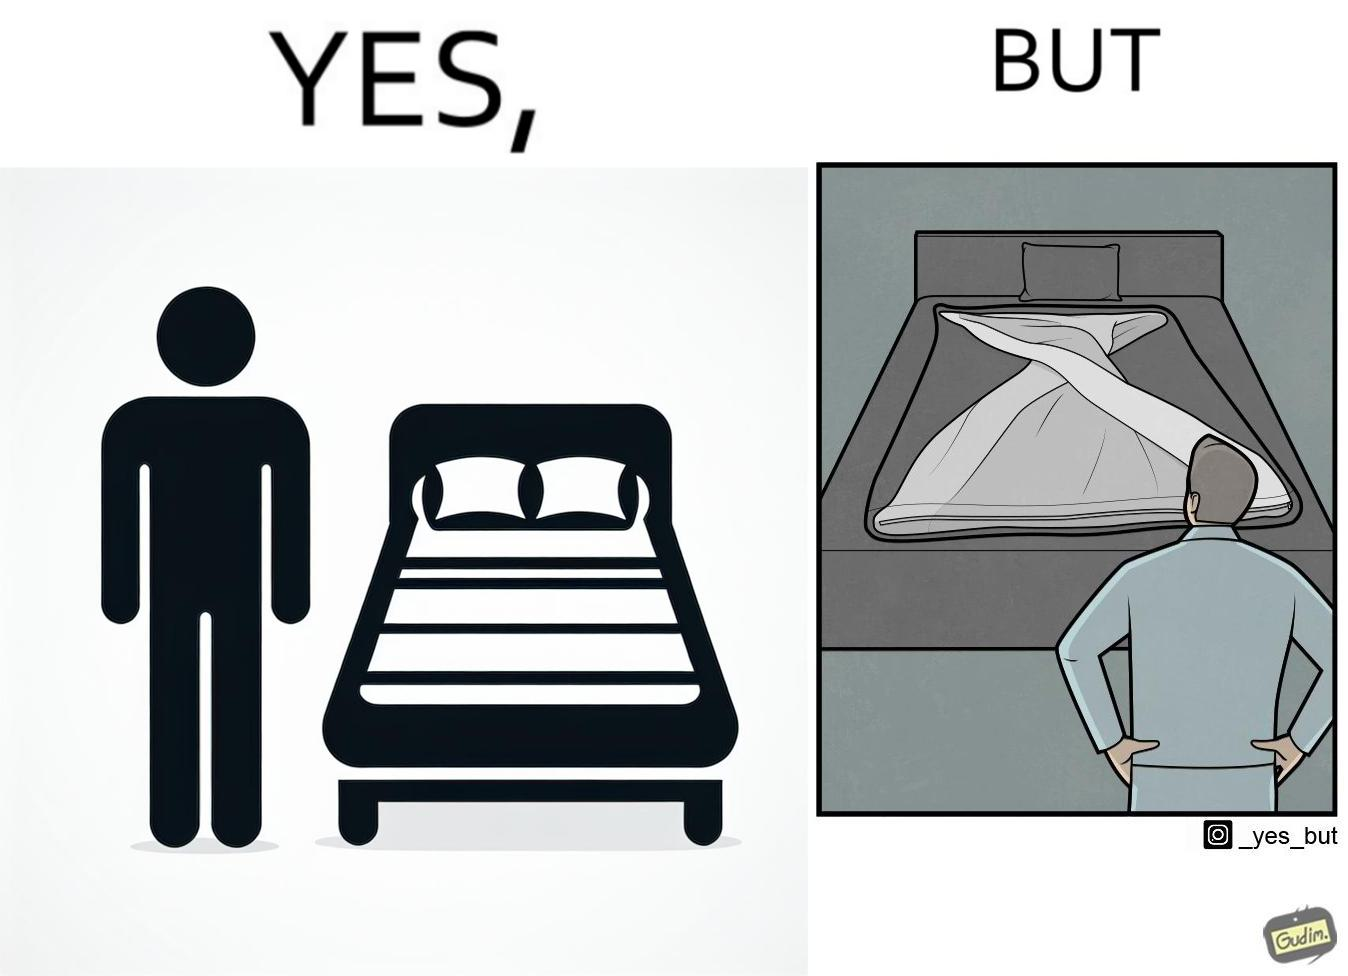What is shown in this image? The image is funny because while the bed seems to be well made with the blanket on top, the actual blanket inside the blanket cover is twisted and not properly set. 